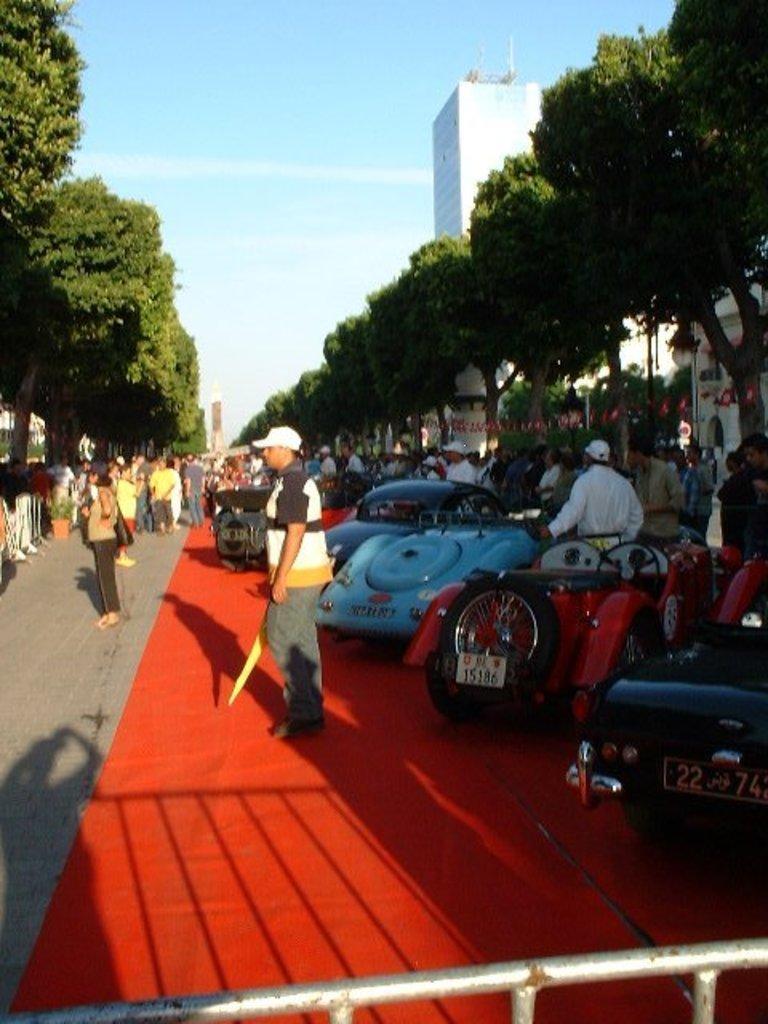Please provide a concise description of this image. In this picture there are cars on the right side of the image and there are people, trees, and buildings on the right and left side of the image, there is a boundary at the bottom side of the image. 